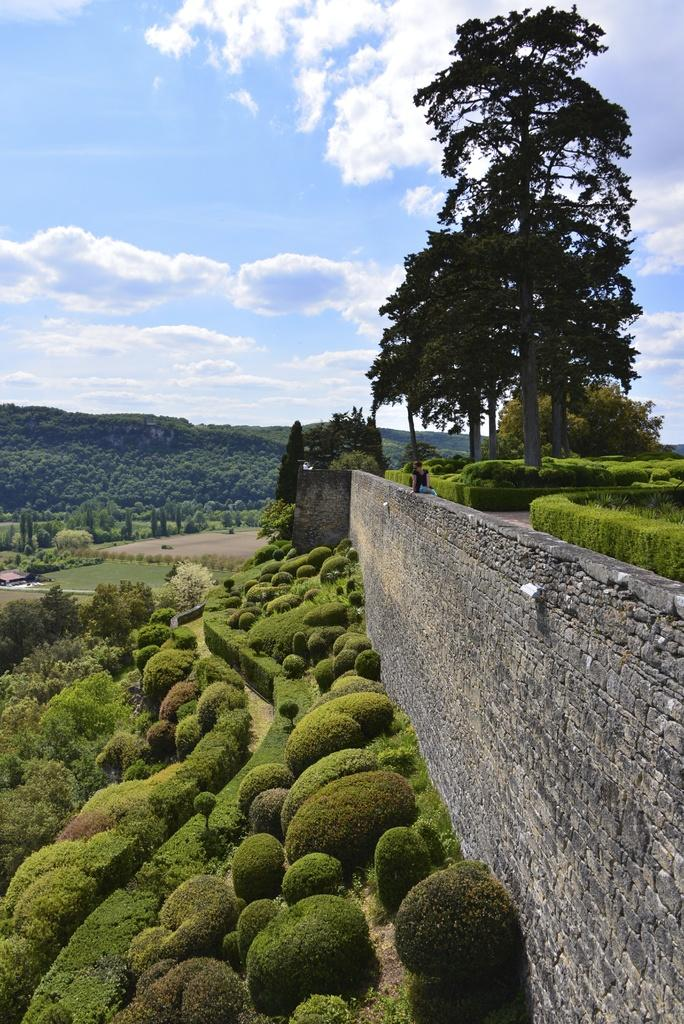What is located on the right side of the image? There is a wall on the right side of the image. What is the main focus of the image? The center of the image contains the sky. What can be seen in the sky? Clouds are visible in the image. What type of vegetation is present in the image? Trees and plants are in the image. What type of ground surface is visible in the image? Grass is visible in the image. How many houses are in the image? There is one house in the image. How many people are in the image? Two persons are in the image. Can you tell me how many snails are crawling on the house in the image? There are no snails present in the image; it only features a house, trees, plants, grass, a wall, sky, clouds, and two persons. 